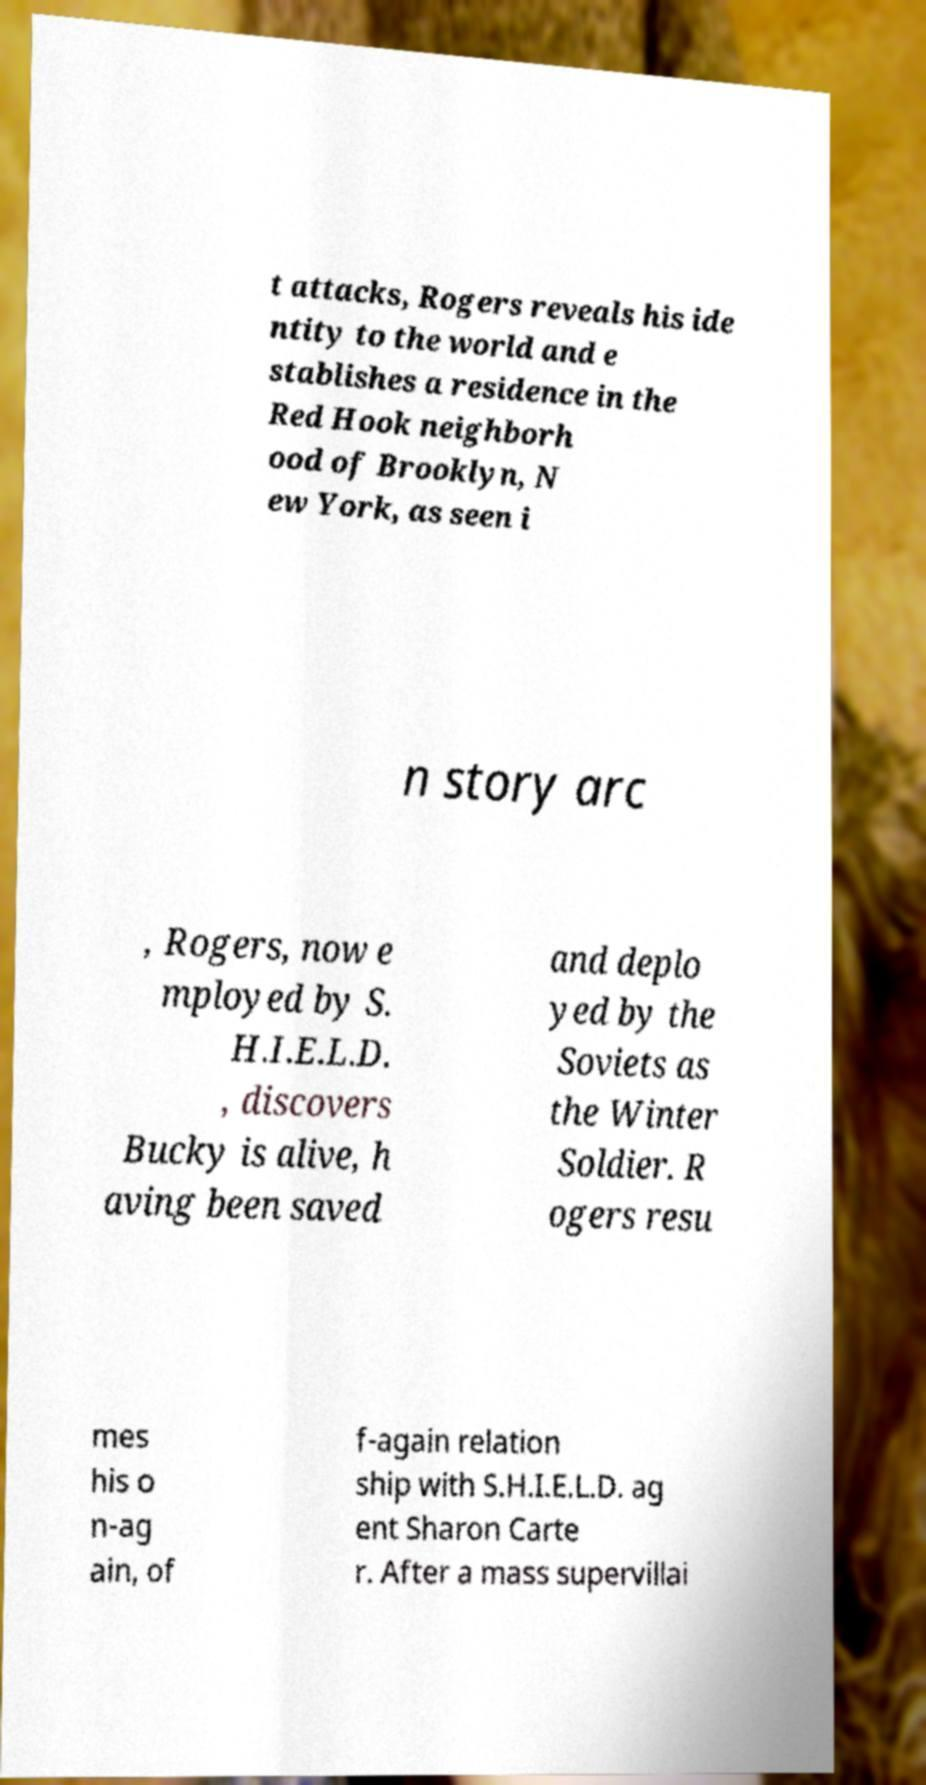There's text embedded in this image that I need extracted. Can you transcribe it verbatim? t attacks, Rogers reveals his ide ntity to the world and e stablishes a residence in the Red Hook neighborh ood of Brooklyn, N ew York, as seen i n story arc , Rogers, now e mployed by S. H.I.E.L.D. , discovers Bucky is alive, h aving been saved and deplo yed by the Soviets as the Winter Soldier. R ogers resu mes his o n-ag ain, of f-again relation ship with S.H.I.E.L.D. ag ent Sharon Carte r. After a mass supervillai 